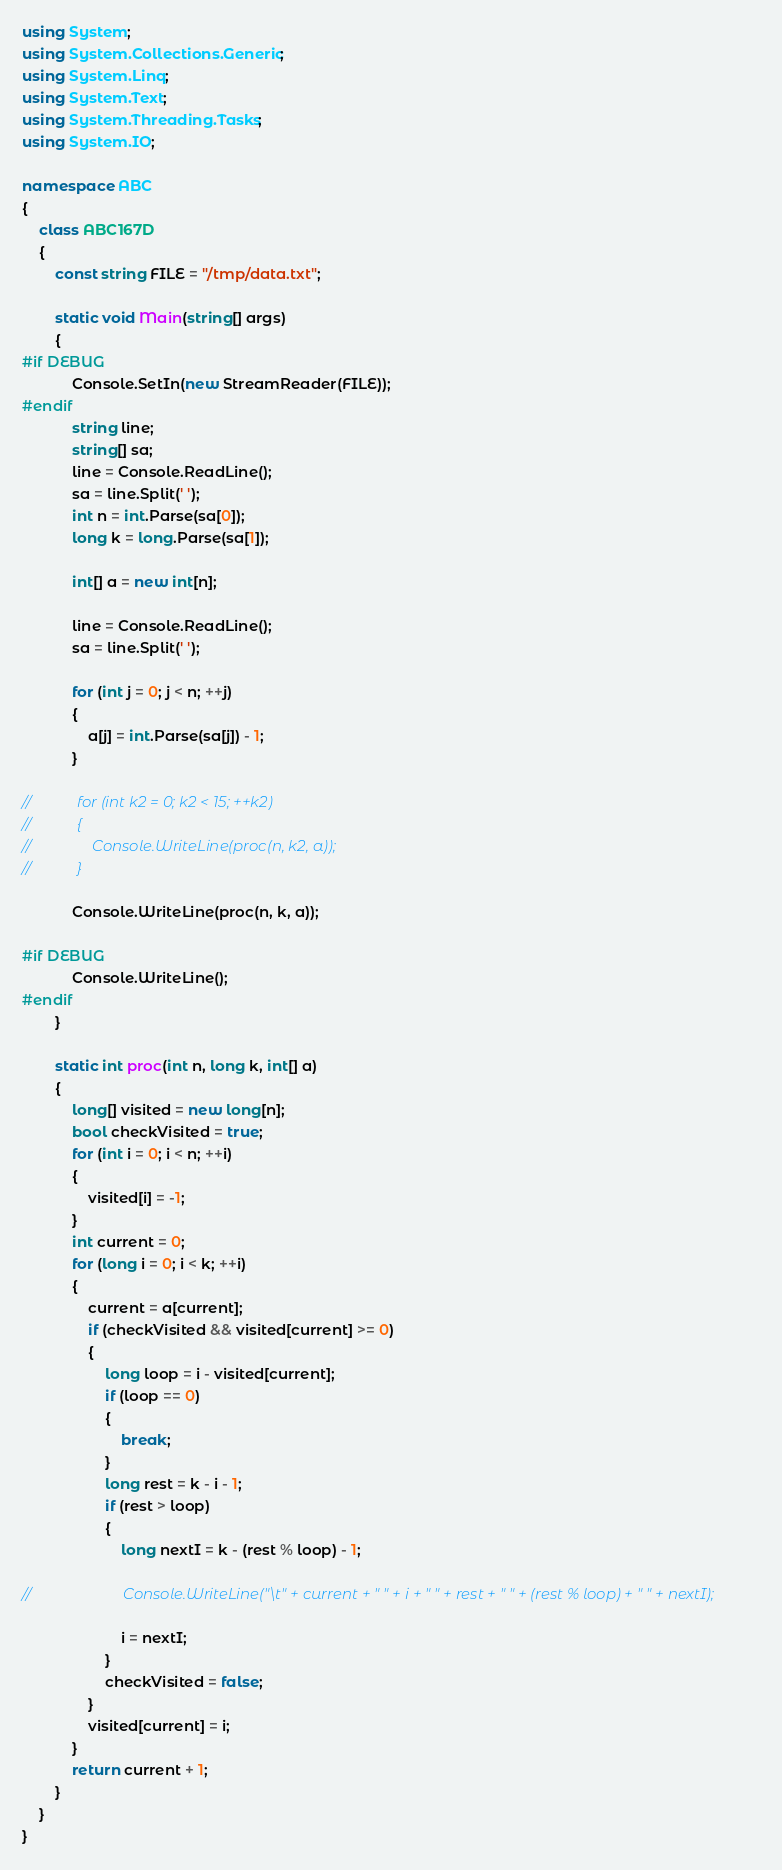Convert code to text. <code><loc_0><loc_0><loc_500><loc_500><_C#_>using System;
using System.Collections.Generic;
using System.Linq;
using System.Text;
using System.Threading.Tasks;
using System.IO;

namespace ABC
{
    class ABC167D
    {
        const string FILE = "/tmp/data.txt";

        static void Main(string[] args)
        {
#if DEBUG
            Console.SetIn(new StreamReader(FILE));
#endif
            string line;
            string[] sa;
            line = Console.ReadLine();
            sa = line.Split(' ');
            int n = int.Parse(sa[0]);
            long k = long.Parse(sa[1]);

            int[] a = new int[n];
            
            line = Console.ReadLine();
            sa = line.Split(' ');

            for (int j = 0; j < n; ++j)
            {
                a[j] = int.Parse(sa[j]) - 1;
            }

//            for (int k2 = 0; k2 < 15; ++k2)
//            {
//                Console.WriteLine(proc(n, k2, a));
//            }

            Console.WriteLine(proc(n, k, a));

#if DEBUG
            Console.WriteLine();
#endif
        }

        static int proc(int n, long k, int[] a)
        {
            long[] visited = new long[n];
            bool checkVisited = true;
            for (int i = 0; i < n; ++i)
            {
                visited[i] = -1;
            }
            int current = 0;
            for (long i = 0; i < k; ++i)
            {
                current = a[current];
                if (checkVisited && visited[current] >= 0)
                {
                    long loop = i - visited[current];
                    if (loop == 0)
                    {
                        break;
                    }
                    long rest = k - i - 1;
                    if (rest > loop)
                    {
                        long nextI = k - (rest % loop) - 1;

//                        Console.WriteLine("\t" + current + " " + i + " " + rest + " " + (rest % loop) + " " + nextI);

                        i = nextI;
                    }
                    checkVisited = false;
                }
                visited[current] = i;
            }
            return current + 1;
        }
    }
}
</code> 